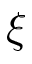Convert formula to latex. <formula><loc_0><loc_0><loc_500><loc_500>\xi</formula> 